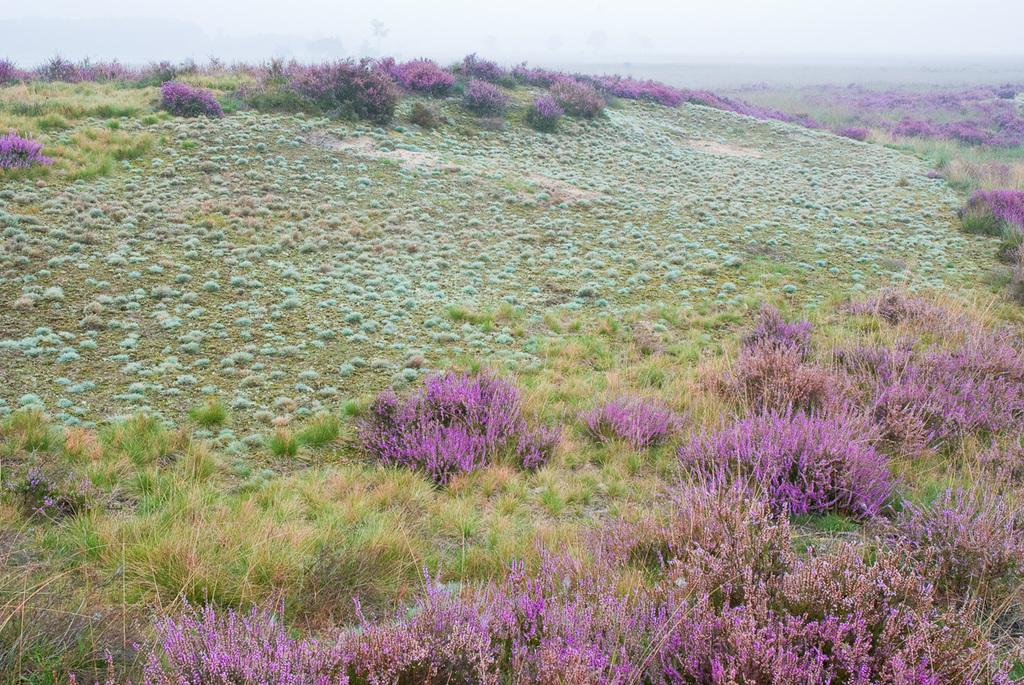What type of living organisms can be seen in the image? Plants can be seen in the image. Where are the plants located? The plants are located on a hill. How many girls are present in the image? There are no girls present in the image; it only features plants on a hill. 